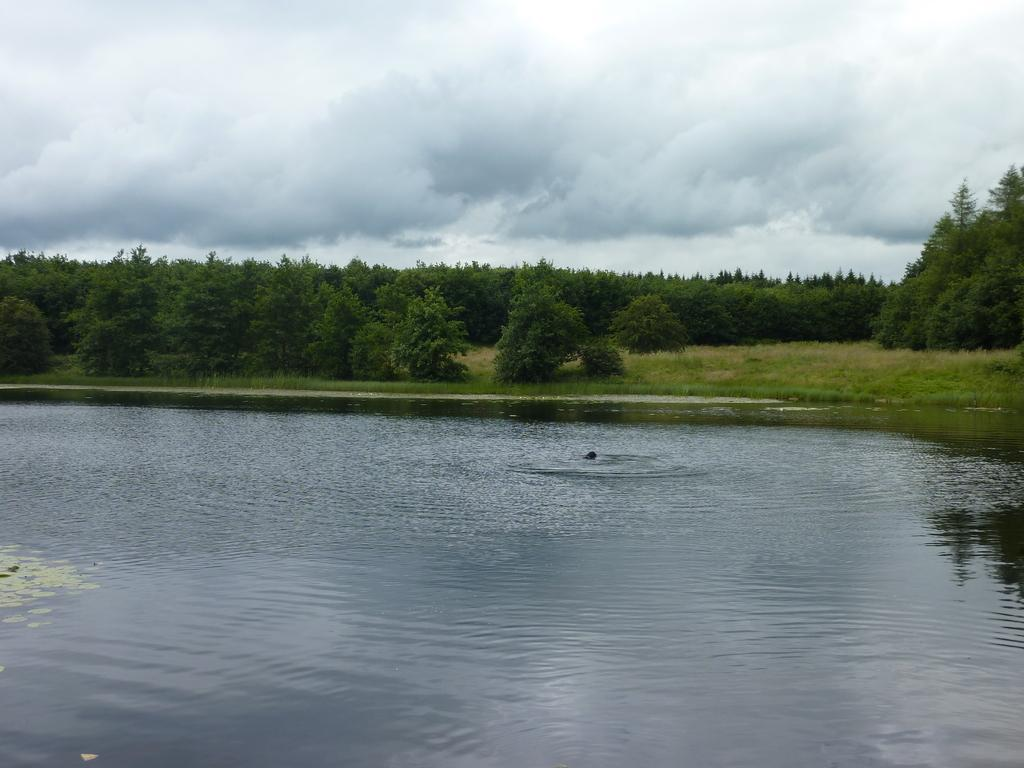What type of vegetation can be seen in the image? There are green color trees in the image. What natural element is visible besides the trees? There is water visible in the image. How would you describe the color of the sky in the image? The sky is in white and blue color. Can you see a nest in the trees in the image? There is no nest visible in the trees in the image. What type of experience can be gained from the image? The image itself does not offer an experience, as it is a static representation. 